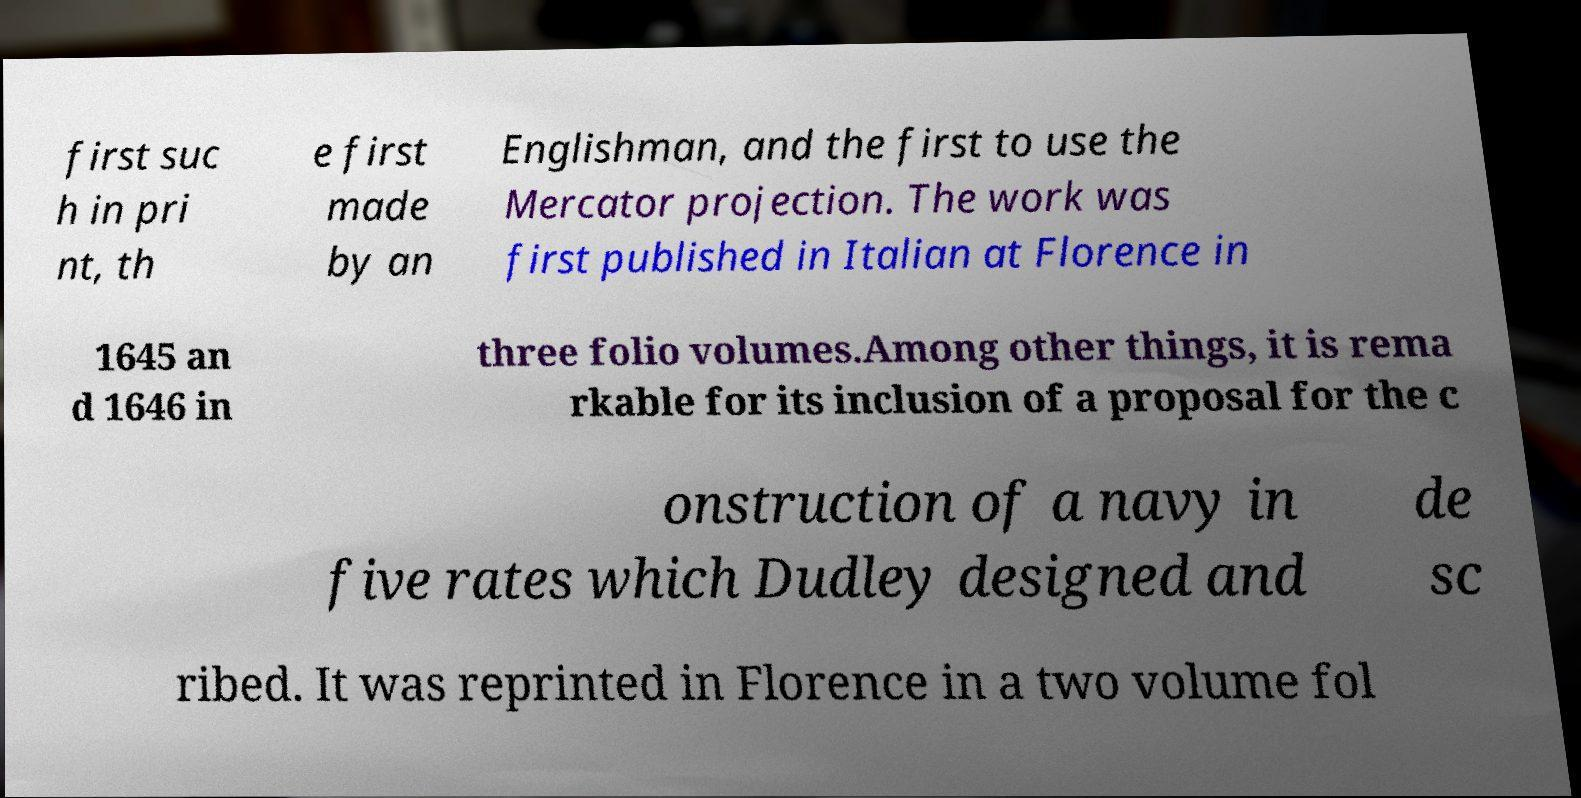For documentation purposes, I need the text within this image transcribed. Could you provide that? first suc h in pri nt, th e first made by an Englishman, and the first to use the Mercator projection. The work was first published in Italian at Florence in 1645 an d 1646 in three folio volumes.Among other things, it is rema rkable for its inclusion of a proposal for the c onstruction of a navy in five rates which Dudley designed and de sc ribed. It was reprinted in Florence in a two volume fol 